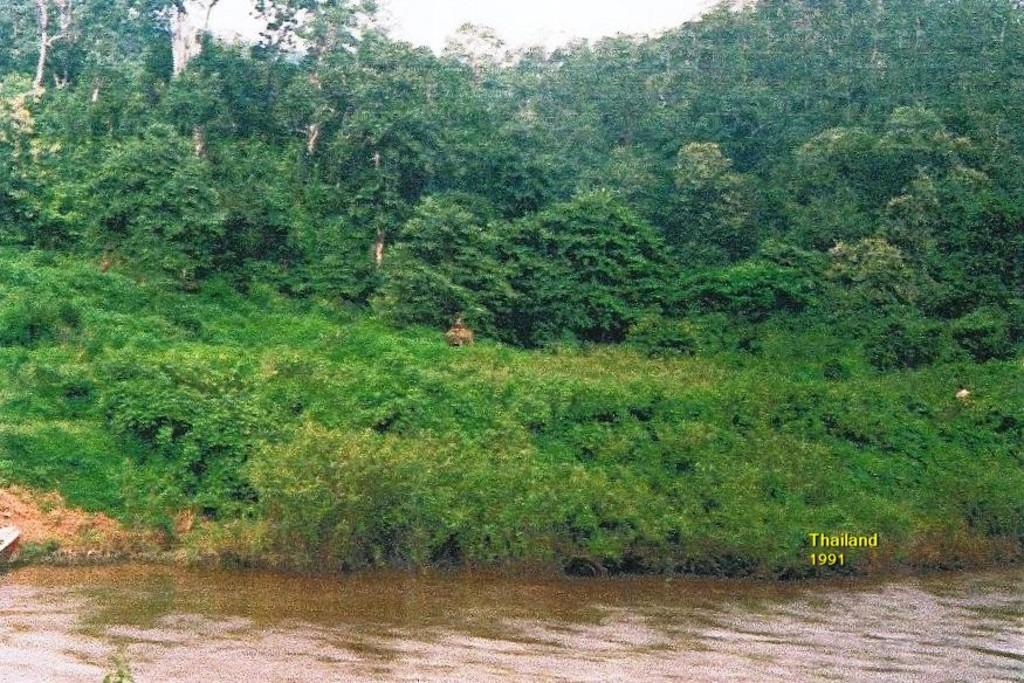Could you give a brief overview of what you see in this image? At the bottom of the image there is water. Behind the water, on the ground there are plants. In the background there are trees. On the right side of the image there is text. 